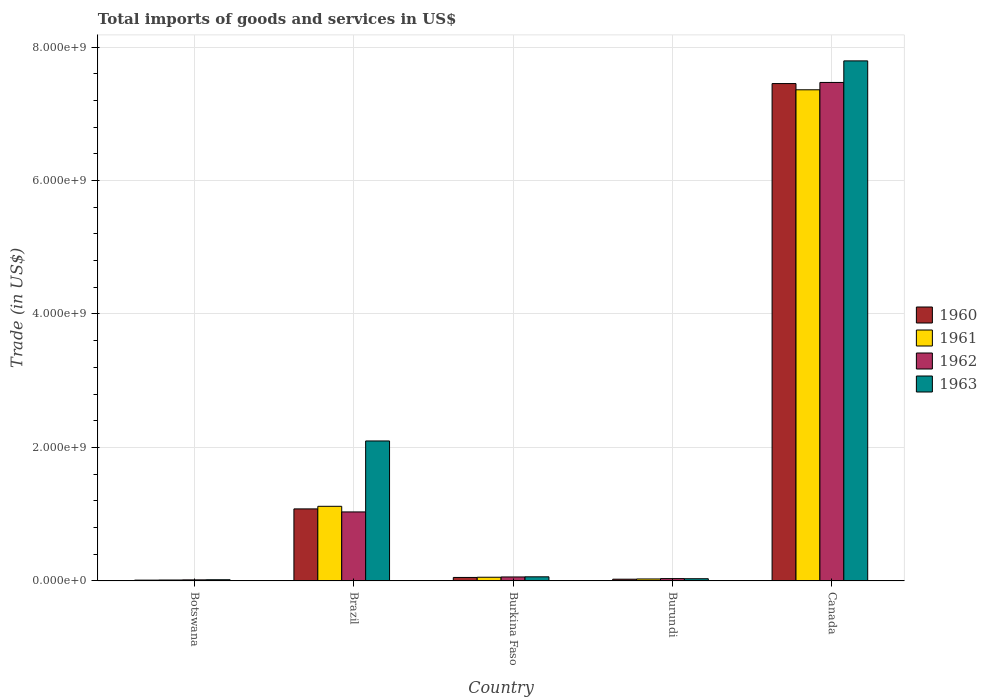How many different coloured bars are there?
Offer a terse response. 4. Are the number of bars per tick equal to the number of legend labels?
Your response must be concise. Yes. How many bars are there on the 2nd tick from the right?
Keep it short and to the point. 4. What is the label of the 5th group of bars from the left?
Your response must be concise. Canada. In how many cases, is the number of bars for a given country not equal to the number of legend labels?
Give a very brief answer. 0. What is the total imports of goods and services in 1962 in Burundi?
Provide a short and direct response. 3.50e+07. Across all countries, what is the maximum total imports of goods and services in 1961?
Provide a succinct answer. 7.36e+09. Across all countries, what is the minimum total imports of goods and services in 1961?
Your answer should be very brief. 1.40e+07. In which country was the total imports of goods and services in 1962 minimum?
Offer a terse response. Botswana. What is the total total imports of goods and services in 1961 in the graph?
Give a very brief answer. 8.58e+09. What is the difference between the total imports of goods and services in 1961 in Botswana and that in Burundi?
Provide a short and direct response. -1.58e+07. What is the difference between the total imports of goods and services in 1962 in Botswana and the total imports of goods and services in 1961 in Burkina Faso?
Provide a succinct answer. -3.93e+07. What is the average total imports of goods and services in 1963 per country?
Your answer should be compact. 2.00e+09. What is the difference between the total imports of goods and services of/in 1961 and total imports of goods and services of/in 1963 in Canada?
Make the answer very short. -4.33e+08. What is the ratio of the total imports of goods and services in 1961 in Botswana to that in Burundi?
Make the answer very short. 0.47. Is the difference between the total imports of goods and services in 1961 in Botswana and Burundi greater than the difference between the total imports of goods and services in 1963 in Botswana and Burundi?
Give a very brief answer. No. What is the difference between the highest and the second highest total imports of goods and services in 1961?
Your answer should be compact. -7.30e+09. What is the difference between the highest and the lowest total imports of goods and services in 1962?
Offer a very short reply. 7.45e+09. What does the 1st bar from the left in Brazil represents?
Your response must be concise. 1960. What does the 1st bar from the right in Brazil represents?
Provide a succinct answer. 1963. How many bars are there?
Provide a short and direct response. 20. How many countries are there in the graph?
Offer a very short reply. 5. Does the graph contain any zero values?
Keep it short and to the point. No. Does the graph contain grids?
Offer a very short reply. Yes. Where does the legend appear in the graph?
Your answer should be compact. Center right. How are the legend labels stacked?
Give a very brief answer. Vertical. What is the title of the graph?
Give a very brief answer. Total imports of goods and services in US$. Does "1969" appear as one of the legend labels in the graph?
Your response must be concise. No. What is the label or title of the X-axis?
Your response must be concise. Country. What is the label or title of the Y-axis?
Your answer should be compact. Trade (in US$). What is the Trade (in US$) of 1960 in Botswana?
Your response must be concise. 1.21e+07. What is the Trade (in US$) in 1961 in Botswana?
Ensure brevity in your answer.  1.40e+07. What is the Trade (in US$) in 1962 in Botswana?
Provide a succinct answer. 1.60e+07. What is the Trade (in US$) of 1963 in Botswana?
Ensure brevity in your answer.  1.80e+07. What is the Trade (in US$) of 1960 in Brazil?
Ensure brevity in your answer.  1.08e+09. What is the Trade (in US$) of 1961 in Brazil?
Offer a terse response. 1.12e+09. What is the Trade (in US$) in 1962 in Brazil?
Give a very brief answer. 1.03e+09. What is the Trade (in US$) in 1963 in Brazil?
Your response must be concise. 2.10e+09. What is the Trade (in US$) of 1960 in Burkina Faso?
Make the answer very short. 5.23e+07. What is the Trade (in US$) of 1961 in Burkina Faso?
Offer a terse response. 5.53e+07. What is the Trade (in US$) of 1962 in Burkina Faso?
Your answer should be compact. 5.96e+07. What is the Trade (in US$) of 1963 in Burkina Faso?
Provide a short and direct response. 6.17e+07. What is the Trade (in US$) in 1960 in Burundi?
Offer a very short reply. 2.62e+07. What is the Trade (in US$) in 1961 in Burundi?
Provide a short and direct response. 2.98e+07. What is the Trade (in US$) of 1962 in Burundi?
Make the answer very short. 3.50e+07. What is the Trade (in US$) of 1963 in Burundi?
Make the answer very short. 3.32e+07. What is the Trade (in US$) in 1960 in Canada?
Offer a very short reply. 7.45e+09. What is the Trade (in US$) of 1961 in Canada?
Provide a succinct answer. 7.36e+09. What is the Trade (in US$) of 1962 in Canada?
Keep it short and to the point. 7.47e+09. What is the Trade (in US$) in 1963 in Canada?
Your response must be concise. 7.79e+09. Across all countries, what is the maximum Trade (in US$) of 1960?
Offer a terse response. 7.45e+09. Across all countries, what is the maximum Trade (in US$) of 1961?
Ensure brevity in your answer.  7.36e+09. Across all countries, what is the maximum Trade (in US$) in 1962?
Ensure brevity in your answer.  7.47e+09. Across all countries, what is the maximum Trade (in US$) of 1963?
Offer a terse response. 7.79e+09. Across all countries, what is the minimum Trade (in US$) of 1960?
Offer a very short reply. 1.21e+07. Across all countries, what is the minimum Trade (in US$) of 1961?
Ensure brevity in your answer.  1.40e+07. Across all countries, what is the minimum Trade (in US$) of 1962?
Offer a very short reply. 1.60e+07. Across all countries, what is the minimum Trade (in US$) in 1963?
Provide a short and direct response. 1.80e+07. What is the total Trade (in US$) in 1960 in the graph?
Your response must be concise. 8.62e+09. What is the total Trade (in US$) of 1961 in the graph?
Provide a succinct answer. 8.58e+09. What is the total Trade (in US$) of 1962 in the graph?
Make the answer very short. 8.61e+09. What is the total Trade (in US$) of 1963 in the graph?
Offer a very short reply. 1.00e+1. What is the difference between the Trade (in US$) of 1960 in Botswana and that in Brazil?
Offer a terse response. -1.07e+09. What is the difference between the Trade (in US$) of 1961 in Botswana and that in Brazil?
Give a very brief answer. -1.10e+09. What is the difference between the Trade (in US$) of 1962 in Botswana and that in Brazil?
Ensure brevity in your answer.  -1.02e+09. What is the difference between the Trade (in US$) in 1963 in Botswana and that in Brazil?
Your answer should be compact. -2.08e+09. What is the difference between the Trade (in US$) of 1960 in Botswana and that in Burkina Faso?
Provide a short and direct response. -4.03e+07. What is the difference between the Trade (in US$) of 1961 in Botswana and that in Burkina Faso?
Provide a succinct answer. -4.13e+07. What is the difference between the Trade (in US$) of 1962 in Botswana and that in Burkina Faso?
Provide a short and direct response. -4.36e+07. What is the difference between the Trade (in US$) of 1963 in Botswana and that in Burkina Faso?
Your response must be concise. -4.37e+07. What is the difference between the Trade (in US$) in 1960 in Botswana and that in Burundi?
Provide a short and direct response. -1.42e+07. What is the difference between the Trade (in US$) of 1961 in Botswana and that in Burundi?
Offer a very short reply. -1.58e+07. What is the difference between the Trade (in US$) of 1962 in Botswana and that in Burundi?
Keep it short and to the point. -1.90e+07. What is the difference between the Trade (in US$) in 1963 in Botswana and that in Burundi?
Provide a short and direct response. -1.52e+07. What is the difference between the Trade (in US$) of 1960 in Botswana and that in Canada?
Keep it short and to the point. -7.44e+09. What is the difference between the Trade (in US$) of 1961 in Botswana and that in Canada?
Keep it short and to the point. -7.35e+09. What is the difference between the Trade (in US$) in 1962 in Botswana and that in Canada?
Your answer should be compact. -7.45e+09. What is the difference between the Trade (in US$) in 1963 in Botswana and that in Canada?
Your answer should be compact. -7.77e+09. What is the difference between the Trade (in US$) of 1960 in Brazil and that in Burkina Faso?
Keep it short and to the point. 1.03e+09. What is the difference between the Trade (in US$) in 1961 in Brazil and that in Burkina Faso?
Make the answer very short. 1.06e+09. What is the difference between the Trade (in US$) of 1962 in Brazil and that in Burkina Faso?
Give a very brief answer. 9.74e+08. What is the difference between the Trade (in US$) in 1963 in Brazil and that in Burkina Faso?
Your answer should be compact. 2.04e+09. What is the difference between the Trade (in US$) in 1960 in Brazil and that in Burundi?
Provide a short and direct response. 1.05e+09. What is the difference between the Trade (in US$) in 1961 in Brazil and that in Burundi?
Your answer should be very brief. 1.09e+09. What is the difference between the Trade (in US$) in 1962 in Brazil and that in Burundi?
Your answer should be very brief. 9.99e+08. What is the difference between the Trade (in US$) of 1963 in Brazil and that in Burundi?
Your answer should be very brief. 2.06e+09. What is the difference between the Trade (in US$) of 1960 in Brazil and that in Canada?
Give a very brief answer. -6.37e+09. What is the difference between the Trade (in US$) of 1961 in Brazil and that in Canada?
Offer a terse response. -6.24e+09. What is the difference between the Trade (in US$) in 1962 in Brazil and that in Canada?
Offer a very short reply. -6.44e+09. What is the difference between the Trade (in US$) of 1963 in Brazil and that in Canada?
Offer a terse response. -5.69e+09. What is the difference between the Trade (in US$) of 1960 in Burkina Faso and that in Burundi?
Ensure brevity in your answer.  2.61e+07. What is the difference between the Trade (in US$) in 1961 in Burkina Faso and that in Burundi?
Provide a succinct answer. 2.56e+07. What is the difference between the Trade (in US$) of 1962 in Burkina Faso and that in Burundi?
Your answer should be very brief. 2.46e+07. What is the difference between the Trade (in US$) of 1963 in Burkina Faso and that in Burundi?
Keep it short and to the point. 2.85e+07. What is the difference between the Trade (in US$) of 1960 in Burkina Faso and that in Canada?
Provide a succinct answer. -7.40e+09. What is the difference between the Trade (in US$) of 1961 in Burkina Faso and that in Canada?
Make the answer very short. -7.30e+09. What is the difference between the Trade (in US$) of 1962 in Burkina Faso and that in Canada?
Provide a succinct answer. -7.41e+09. What is the difference between the Trade (in US$) of 1963 in Burkina Faso and that in Canada?
Keep it short and to the point. -7.73e+09. What is the difference between the Trade (in US$) in 1960 in Burundi and that in Canada?
Give a very brief answer. -7.43e+09. What is the difference between the Trade (in US$) of 1961 in Burundi and that in Canada?
Ensure brevity in your answer.  -7.33e+09. What is the difference between the Trade (in US$) in 1962 in Burundi and that in Canada?
Offer a very short reply. -7.43e+09. What is the difference between the Trade (in US$) in 1963 in Burundi and that in Canada?
Your response must be concise. -7.76e+09. What is the difference between the Trade (in US$) of 1960 in Botswana and the Trade (in US$) of 1961 in Brazil?
Offer a terse response. -1.11e+09. What is the difference between the Trade (in US$) of 1960 in Botswana and the Trade (in US$) of 1962 in Brazil?
Make the answer very short. -1.02e+09. What is the difference between the Trade (in US$) in 1960 in Botswana and the Trade (in US$) in 1963 in Brazil?
Your answer should be compact. -2.09e+09. What is the difference between the Trade (in US$) of 1961 in Botswana and the Trade (in US$) of 1962 in Brazil?
Ensure brevity in your answer.  -1.02e+09. What is the difference between the Trade (in US$) of 1961 in Botswana and the Trade (in US$) of 1963 in Brazil?
Ensure brevity in your answer.  -2.08e+09. What is the difference between the Trade (in US$) in 1962 in Botswana and the Trade (in US$) in 1963 in Brazil?
Provide a short and direct response. -2.08e+09. What is the difference between the Trade (in US$) of 1960 in Botswana and the Trade (in US$) of 1961 in Burkina Faso?
Your answer should be compact. -4.32e+07. What is the difference between the Trade (in US$) of 1960 in Botswana and the Trade (in US$) of 1962 in Burkina Faso?
Offer a very short reply. -4.76e+07. What is the difference between the Trade (in US$) in 1960 in Botswana and the Trade (in US$) in 1963 in Burkina Faso?
Offer a very short reply. -4.97e+07. What is the difference between the Trade (in US$) of 1961 in Botswana and the Trade (in US$) of 1962 in Burkina Faso?
Provide a short and direct response. -4.56e+07. What is the difference between the Trade (in US$) in 1961 in Botswana and the Trade (in US$) in 1963 in Burkina Faso?
Offer a very short reply. -4.78e+07. What is the difference between the Trade (in US$) of 1962 in Botswana and the Trade (in US$) of 1963 in Burkina Faso?
Your answer should be compact. -4.58e+07. What is the difference between the Trade (in US$) in 1960 in Botswana and the Trade (in US$) in 1961 in Burundi?
Your answer should be compact. -1.77e+07. What is the difference between the Trade (in US$) of 1960 in Botswana and the Trade (in US$) of 1962 in Burundi?
Your answer should be compact. -2.29e+07. What is the difference between the Trade (in US$) in 1960 in Botswana and the Trade (in US$) in 1963 in Burundi?
Make the answer very short. -2.12e+07. What is the difference between the Trade (in US$) of 1961 in Botswana and the Trade (in US$) of 1962 in Burundi?
Your response must be concise. -2.10e+07. What is the difference between the Trade (in US$) of 1961 in Botswana and the Trade (in US$) of 1963 in Burundi?
Give a very brief answer. -1.93e+07. What is the difference between the Trade (in US$) of 1962 in Botswana and the Trade (in US$) of 1963 in Burundi?
Provide a succinct answer. -1.73e+07. What is the difference between the Trade (in US$) of 1960 in Botswana and the Trade (in US$) of 1961 in Canada?
Provide a succinct answer. -7.35e+09. What is the difference between the Trade (in US$) of 1960 in Botswana and the Trade (in US$) of 1962 in Canada?
Make the answer very short. -7.46e+09. What is the difference between the Trade (in US$) of 1960 in Botswana and the Trade (in US$) of 1963 in Canada?
Ensure brevity in your answer.  -7.78e+09. What is the difference between the Trade (in US$) of 1961 in Botswana and the Trade (in US$) of 1962 in Canada?
Keep it short and to the point. -7.46e+09. What is the difference between the Trade (in US$) in 1961 in Botswana and the Trade (in US$) in 1963 in Canada?
Offer a terse response. -7.78e+09. What is the difference between the Trade (in US$) of 1962 in Botswana and the Trade (in US$) of 1963 in Canada?
Your answer should be compact. -7.78e+09. What is the difference between the Trade (in US$) in 1960 in Brazil and the Trade (in US$) in 1961 in Burkina Faso?
Your response must be concise. 1.02e+09. What is the difference between the Trade (in US$) of 1960 in Brazil and the Trade (in US$) of 1962 in Burkina Faso?
Your answer should be very brief. 1.02e+09. What is the difference between the Trade (in US$) of 1960 in Brazil and the Trade (in US$) of 1963 in Burkina Faso?
Your answer should be compact. 1.02e+09. What is the difference between the Trade (in US$) in 1961 in Brazil and the Trade (in US$) in 1962 in Burkina Faso?
Ensure brevity in your answer.  1.06e+09. What is the difference between the Trade (in US$) in 1961 in Brazil and the Trade (in US$) in 1963 in Burkina Faso?
Provide a short and direct response. 1.06e+09. What is the difference between the Trade (in US$) in 1962 in Brazil and the Trade (in US$) in 1963 in Burkina Faso?
Your answer should be compact. 9.72e+08. What is the difference between the Trade (in US$) of 1960 in Brazil and the Trade (in US$) of 1961 in Burundi?
Offer a terse response. 1.05e+09. What is the difference between the Trade (in US$) in 1960 in Brazil and the Trade (in US$) in 1962 in Burundi?
Your answer should be compact. 1.04e+09. What is the difference between the Trade (in US$) of 1960 in Brazil and the Trade (in US$) of 1963 in Burundi?
Provide a succinct answer. 1.05e+09. What is the difference between the Trade (in US$) in 1961 in Brazil and the Trade (in US$) in 1962 in Burundi?
Offer a terse response. 1.08e+09. What is the difference between the Trade (in US$) of 1961 in Brazil and the Trade (in US$) of 1963 in Burundi?
Offer a terse response. 1.09e+09. What is the difference between the Trade (in US$) in 1962 in Brazil and the Trade (in US$) in 1963 in Burundi?
Give a very brief answer. 1.00e+09. What is the difference between the Trade (in US$) in 1960 in Brazil and the Trade (in US$) in 1961 in Canada?
Provide a short and direct response. -6.28e+09. What is the difference between the Trade (in US$) in 1960 in Brazil and the Trade (in US$) in 1962 in Canada?
Ensure brevity in your answer.  -6.39e+09. What is the difference between the Trade (in US$) of 1960 in Brazil and the Trade (in US$) of 1963 in Canada?
Your answer should be very brief. -6.71e+09. What is the difference between the Trade (in US$) of 1961 in Brazil and the Trade (in US$) of 1962 in Canada?
Ensure brevity in your answer.  -6.35e+09. What is the difference between the Trade (in US$) of 1961 in Brazil and the Trade (in US$) of 1963 in Canada?
Offer a very short reply. -6.67e+09. What is the difference between the Trade (in US$) of 1962 in Brazil and the Trade (in US$) of 1963 in Canada?
Offer a very short reply. -6.76e+09. What is the difference between the Trade (in US$) of 1960 in Burkina Faso and the Trade (in US$) of 1961 in Burundi?
Your response must be concise. 2.26e+07. What is the difference between the Trade (in US$) in 1960 in Burkina Faso and the Trade (in US$) in 1962 in Burundi?
Give a very brief answer. 1.73e+07. What is the difference between the Trade (in US$) of 1960 in Burkina Faso and the Trade (in US$) of 1963 in Burundi?
Ensure brevity in your answer.  1.91e+07. What is the difference between the Trade (in US$) in 1961 in Burkina Faso and the Trade (in US$) in 1962 in Burundi?
Your answer should be compact. 2.03e+07. What is the difference between the Trade (in US$) in 1961 in Burkina Faso and the Trade (in US$) in 1963 in Burundi?
Ensure brevity in your answer.  2.21e+07. What is the difference between the Trade (in US$) of 1962 in Burkina Faso and the Trade (in US$) of 1963 in Burundi?
Your response must be concise. 2.64e+07. What is the difference between the Trade (in US$) in 1960 in Burkina Faso and the Trade (in US$) in 1961 in Canada?
Keep it short and to the point. -7.31e+09. What is the difference between the Trade (in US$) in 1960 in Burkina Faso and the Trade (in US$) in 1962 in Canada?
Keep it short and to the point. -7.42e+09. What is the difference between the Trade (in US$) of 1960 in Burkina Faso and the Trade (in US$) of 1963 in Canada?
Provide a succinct answer. -7.74e+09. What is the difference between the Trade (in US$) of 1961 in Burkina Faso and the Trade (in US$) of 1962 in Canada?
Provide a succinct answer. -7.41e+09. What is the difference between the Trade (in US$) in 1961 in Burkina Faso and the Trade (in US$) in 1963 in Canada?
Provide a succinct answer. -7.74e+09. What is the difference between the Trade (in US$) of 1962 in Burkina Faso and the Trade (in US$) of 1963 in Canada?
Make the answer very short. -7.73e+09. What is the difference between the Trade (in US$) in 1960 in Burundi and the Trade (in US$) in 1961 in Canada?
Ensure brevity in your answer.  -7.33e+09. What is the difference between the Trade (in US$) in 1960 in Burundi and the Trade (in US$) in 1962 in Canada?
Provide a succinct answer. -7.44e+09. What is the difference between the Trade (in US$) of 1960 in Burundi and the Trade (in US$) of 1963 in Canada?
Provide a succinct answer. -7.77e+09. What is the difference between the Trade (in US$) in 1961 in Burundi and the Trade (in US$) in 1962 in Canada?
Offer a terse response. -7.44e+09. What is the difference between the Trade (in US$) of 1961 in Burundi and the Trade (in US$) of 1963 in Canada?
Keep it short and to the point. -7.76e+09. What is the difference between the Trade (in US$) of 1962 in Burundi and the Trade (in US$) of 1963 in Canada?
Make the answer very short. -7.76e+09. What is the average Trade (in US$) of 1960 per country?
Keep it short and to the point. 1.72e+09. What is the average Trade (in US$) in 1961 per country?
Your answer should be very brief. 1.72e+09. What is the average Trade (in US$) of 1962 per country?
Ensure brevity in your answer.  1.72e+09. What is the average Trade (in US$) in 1963 per country?
Provide a succinct answer. 2.00e+09. What is the difference between the Trade (in US$) of 1960 and Trade (in US$) of 1961 in Botswana?
Provide a succinct answer. -1.94e+06. What is the difference between the Trade (in US$) in 1960 and Trade (in US$) in 1962 in Botswana?
Give a very brief answer. -3.93e+06. What is the difference between the Trade (in US$) of 1960 and Trade (in US$) of 1963 in Botswana?
Make the answer very short. -5.98e+06. What is the difference between the Trade (in US$) in 1961 and Trade (in US$) in 1962 in Botswana?
Your answer should be compact. -1.99e+06. What is the difference between the Trade (in US$) of 1961 and Trade (in US$) of 1963 in Botswana?
Your answer should be very brief. -4.04e+06. What is the difference between the Trade (in US$) in 1962 and Trade (in US$) in 1963 in Botswana?
Provide a succinct answer. -2.05e+06. What is the difference between the Trade (in US$) in 1960 and Trade (in US$) in 1961 in Brazil?
Provide a short and direct response. -3.89e+07. What is the difference between the Trade (in US$) in 1960 and Trade (in US$) in 1962 in Brazil?
Make the answer very short. 4.54e+07. What is the difference between the Trade (in US$) of 1960 and Trade (in US$) of 1963 in Brazil?
Give a very brief answer. -1.02e+09. What is the difference between the Trade (in US$) in 1961 and Trade (in US$) in 1962 in Brazil?
Your answer should be very brief. 8.43e+07. What is the difference between the Trade (in US$) in 1961 and Trade (in US$) in 1963 in Brazil?
Your answer should be very brief. -9.79e+08. What is the difference between the Trade (in US$) of 1962 and Trade (in US$) of 1963 in Brazil?
Offer a terse response. -1.06e+09. What is the difference between the Trade (in US$) of 1960 and Trade (in US$) of 1961 in Burkina Faso?
Your response must be concise. -2.96e+06. What is the difference between the Trade (in US$) in 1960 and Trade (in US$) in 1962 in Burkina Faso?
Keep it short and to the point. -7.27e+06. What is the difference between the Trade (in US$) in 1960 and Trade (in US$) in 1963 in Burkina Faso?
Give a very brief answer. -9.40e+06. What is the difference between the Trade (in US$) of 1961 and Trade (in US$) of 1962 in Burkina Faso?
Give a very brief answer. -4.31e+06. What is the difference between the Trade (in US$) in 1961 and Trade (in US$) in 1963 in Burkina Faso?
Your answer should be compact. -6.44e+06. What is the difference between the Trade (in US$) of 1962 and Trade (in US$) of 1963 in Burkina Faso?
Your answer should be compact. -2.13e+06. What is the difference between the Trade (in US$) of 1960 and Trade (in US$) of 1961 in Burundi?
Your answer should be very brief. -3.50e+06. What is the difference between the Trade (in US$) in 1960 and Trade (in US$) in 1962 in Burundi?
Make the answer very short. -8.75e+06. What is the difference between the Trade (in US$) of 1960 and Trade (in US$) of 1963 in Burundi?
Your answer should be very brief. -7.00e+06. What is the difference between the Trade (in US$) in 1961 and Trade (in US$) in 1962 in Burundi?
Your answer should be very brief. -5.25e+06. What is the difference between the Trade (in US$) in 1961 and Trade (in US$) in 1963 in Burundi?
Your response must be concise. -3.50e+06. What is the difference between the Trade (in US$) of 1962 and Trade (in US$) of 1963 in Burundi?
Ensure brevity in your answer.  1.75e+06. What is the difference between the Trade (in US$) in 1960 and Trade (in US$) in 1961 in Canada?
Offer a terse response. 9.32e+07. What is the difference between the Trade (in US$) in 1960 and Trade (in US$) in 1962 in Canada?
Keep it short and to the point. -1.67e+07. What is the difference between the Trade (in US$) in 1960 and Trade (in US$) in 1963 in Canada?
Offer a terse response. -3.40e+08. What is the difference between the Trade (in US$) in 1961 and Trade (in US$) in 1962 in Canada?
Keep it short and to the point. -1.10e+08. What is the difference between the Trade (in US$) in 1961 and Trade (in US$) in 1963 in Canada?
Provide a short and direct response. -4.33e+08. What is the difference between the Trade (in US$) of 1962 and Trade (in US$) of 1963 in Canada?
Ensure brevity in your answer.  -3.23e+08. What is the ratio of the Trade (in US$) of 1960 in Botswana to that in Brazil?
Make the answer very short. 0.01. What is the ratio of the Trade (in US$) of 1961 in Botswana to that in Brazil?
Your answer should be very brief. 0.01. What is the ratio of the Trade (in US$) in 1962 in Botswana to that in Brazil?
Ensure brevity in your answer.  0.02. What is the ratio of the Trade (in US$) of 1963 in Botswana to that in Brazil?
Ensure brevity in your answer.  0.01. What is the ratio of the Trade (in US$) in 1960 in Botswana to that in Burkina Faso?
Ensure brevity in your answer.  0.23. What is the ratio of the Trade (in US$) in 1961 in Botswana to that in Burkina Faso?
Your answer should be compact. 0.25. What is the ratio of the Trade (in US$) of 1962 in Botswana to that in Burkina Faso?
Keep it short and to the point. 0.27. What is the ratio of the Trade (in US$) of 1963 in Botswana to that in Burkina Faso?
Provide a short and direct response. 0.29. What is the ratio of the Trade (in US$) of 1960 in Botswana to that in Burundi?
Your response must be concise. 0.46. What is the ratio of the Trade (in US$) of 1961 in Botswana to that in Burundi?
Give a very brief answer. 0.47. What is the ratio of the Trade (in US$) in 1962 in Botswana to that in Burundi?
Give a very brief answer. 0.46. What is the ratio of the Trade (in US$) of 1963 in Botswana to that in Burundi?
Provide a succinct answer. 0.54. What is the ratio of the Trade (in US$) of 1960 in Botswana to that in Canada?
Provide a succinct answer. 0. What is the ratio of the Trade (in US$) of 1961 in Botswana to that in Canada?
Provide a short and direct response. 0. What is the ratio of the Trade (in US$) of 1962 in Botswana to that in Canada?
Provide a succinct answer. 0. What is the ratio of the Trade (in US$) of 1963 in Botswana to that in Canada?
Ensure brevity in your answer.  0. What is the ratio of the Trade (in US$) of 1960 in Brazil to that in Burkina Faso?
Offer a very short reply. 20.62. What is the ratio of the Trade (in US$) of 1961 in Brazil to that in Burkina Faso?
Your response must be concise. 20.22. What is the ratio of the Trade (in US$) in 1962 in Brazil to that in Burkina Faso?
Give a very brief answer. 17.34. What is the ratio of the Trade (in US$) of 1963 in Brazil to that in Burkina Faso?
Ensure brevity in your answer.  33.97. What is the ratio of the Trade (in US$) of 1960 in Brazil to that in Burundi?
Your answer should be compact. 41.12. What is the ratio of the Trade (in US$) in 1961 in Brazil to that in Burundi?
Provide a short and direct response. 37.59. What is the ratio of the Trade (in US$) of 1962 in Brazil to that in Burundi?
Your answer should be very brief. 29.54. What is the ratio of the Trade (in US$) in 1963 in Brazil to that in Burundi?
Provide a short and direct response. 63.08. What is the ratio of the Trade (in US$) in 1960 in Brazil to that in Canada?
Your answer should be compact. 0.14. What is the ratio of the Trade (in US$) of 1961 in Brazil to that in Canada?
Offer a terse response. 0.15. What is the ratio of the Trade (in US$) of 1962 in Brazil to that in Canada?
Ensure brevity in your answer.  0.14. What is the ratio of the Trade (in US$) of 1963 in Brazil to that in Canada?
Your response must be concise. 0.27. What is the ratio of the Trade (in US$) of 1960 in Burkina Faso to that in Burundi?
Your answer should be compact. 1.99. What is the ratio of the Trade (in US$) in 1961 in Burkina Faso to that in Burundi?
Make the answer very short. 1.86. What is the ratio of the Trade (in US$) of 1962 in Burkina Faso to that in Burundi?
Provide a succinct answer. 1.7. What is the ratio of the Trade (in US$) in 1963 in Burkina Faso to that in Burundi?
Make the answer very short. 1.86. What is the ratio of the Trade (in US$) of 1960 in Burkina Faso to that in Canada?
Offer a terse response. 0.01. What is the ratio of the Trade (in US$) in 1961 in Burkina Faso to that in Canada?
Give a very brief answer. 0.01. What is the ratio of the Trade (in US$) of 1962 in Burkina Faso to that in Canada?
Ensure brevity in your answer.  0.01. What is the ratio of the Trade (in US$) in 1963 in Burkina Faso to that in Canada?
Offer a terse response. 0.01. What is the ratio of the Trade (in US$) in 1960 in Burundi to that in Canada?
Your answer should be very brief. 0. What is the ratio of the Trade (in US$) in 1961 in Burundi to that in Canada?
Offer a terse response. 0. What is the ratio of the Trade (in US$) of 1962 in Burundi to that in Canada?
Give a very brief answer. 0. What is the ratio of the Trade (in US$) of 1963 in Burundi to that in Canada?
Give a very brief answer. 0. What is the difference between the highest and the second highest Trade (in US$) of 1960?
Provide a short and direct response. 6.37e+09. What is the difference between the highest and the second highest Trade (in US$) in 1961?
Offer a very short reply. 6.24e+09. What is the difference between the highest and the second highest Trade (in US$) of 1962?
Offer a very short reply. 6.44e+09. What is the difference between the highest and the second highest Trade (in US$) in 1963?
Your response must be concise. 5.69e+09. What is the difference between the highest and the lowest Trade (in US$) of 1960?
Your response must be concise. 7.44e+09. What is the difference between the highest and the lowest Trade (in US$) of 1961?
Your answer should be compact. 7.35e+09. What is the difference between the highest and the lowest Trade (in US$) of 1962?
Make the answer very short. 7.45e+09. What is the difference between the highest and the lowest Trade (in US$) in 1963?
Your answer should be very brief. 7.77e+09. 